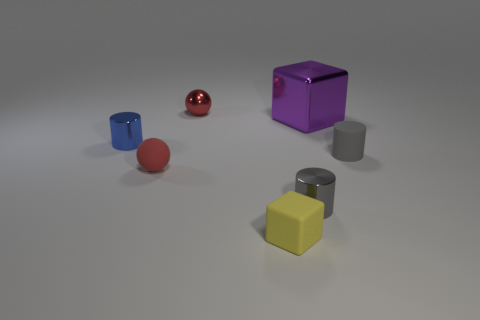The gray matte cylinder is what size?
Offer a very short reply. Small. What number of things are tiny blue cylinders or tiny gray rubber cylinders?
Your response must be concise. 2. Do the small gray object to the left of the large metal object and the block that is to the left of the big purple block have the same material?
Your answer should be very brief. No. The tiny sphere that is the same material as the large purple cube is what color?
Give a very brief answer. Red. What number of other objects have the same size as the red shiny thing?
Your answer should be very brief. 5. What number of other things are the same color as the rubber ball?
Provide a succinct answer. 1. Are there any other things that have the same size as the red metallic object?
Your answer should be compact. Yes. Does the red thing that is behind the large shiny thing have the same shape as the red thing that is in front of the blue cylinder?
Make the answer very short. Yes. The yellow object that is the same size as the blue thing is what shape?
Keep it short and to the point. Cube. Is the number of purple things in front of the big purple cube the same as the number of objects that are behind the small red matte ball?
Offer a very short reply. No. 